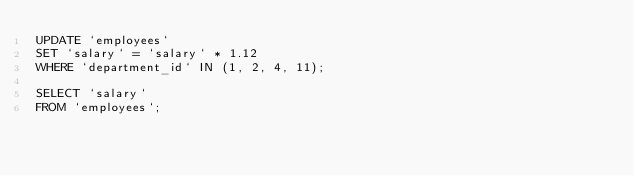Convert code to text. <code><loc_0><loc_0><loc_500><loc_500><_SQL_>UPDATE `employees`
SET `salary` = `salary` * 1.12
WHERE `department_id` IN (1, 2, 4, 11);

SELECT `salary`
FROM `employees`;</code> 